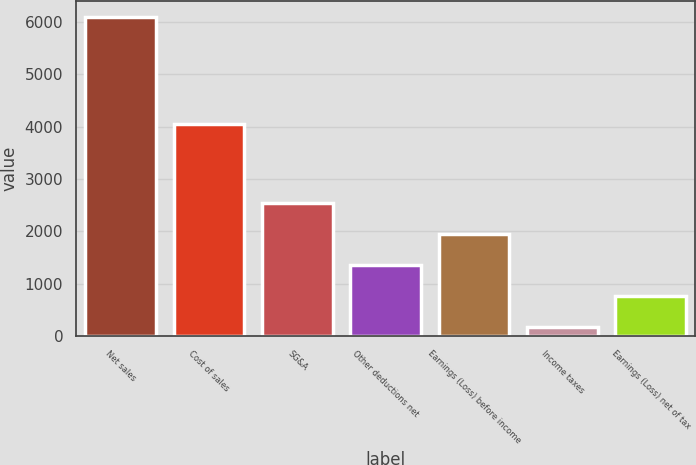Convert chart to OTSL. <chart><loc_0><loc_0><loc_500><loc_500><bar_chart><fcel>Net sales<fcel>Cost of sales<fcel>SG&A<fcel>Other deductions net<fcel>Earnings (Loss) before income<fcel>Income taxes<fcel>Earnings (Loss) net of tax<nl><fcel>6094<fcel>4054<fcel>2534.2<fcel>1347.6<fcel>1940.9<fcel>161<fcel>754.3<nl></chart> 